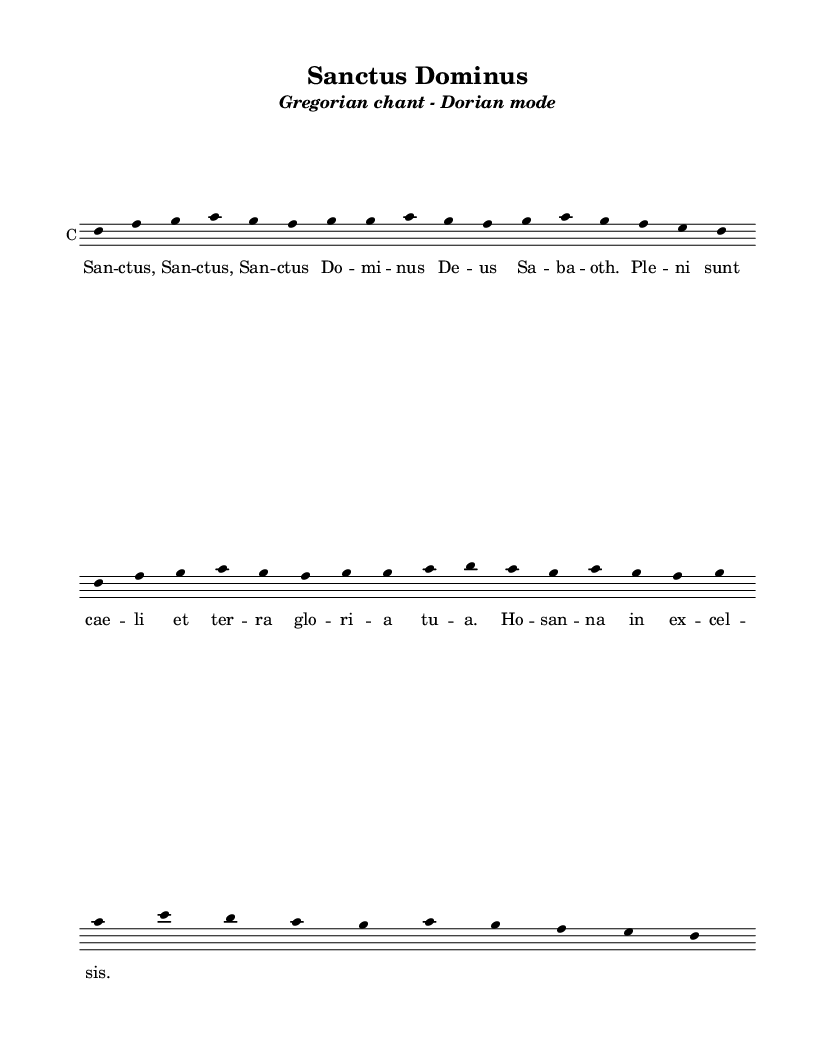What is the key signature of this music? The key signature indicates that the piece is in Dorian mode, which typically has a tonic note of D. Therefore, the key signature contains two sharps.
Answer: Dorian mode What is the mode of the chant? The header indicates that this piece is in Dorian mode, which is characteristic of medieval liturgical music.
Answer: Dorian How many repetitions of the word "Sanctus" are there in the text? The lyrics line shows that the word "Sanctus" is sung three times, as indicated by its repeated appearance at the beginning of the lines.
Answer: Three What is the title of this piece? The title is clearly labeled at the top of the sheet music, which reads "Sanctus Dominus."
Answer: Sanctus Dominus How many phrases are in the melody? The melody can be divided into four distinctive phrases as indicated by the natural breaks and the structure of the musical notes.
Answer: Four What is the overall form of the text? The structure of the lyrics suggests a repetitive form, typical in Gregorian chant, where key phrases are reiterated for emphasis.
Answer: Repetitive What note starts the melody? The first note of the melody is clearly indicated as D in the staff, setting the main tonal focus of the piece.
Answer: D 